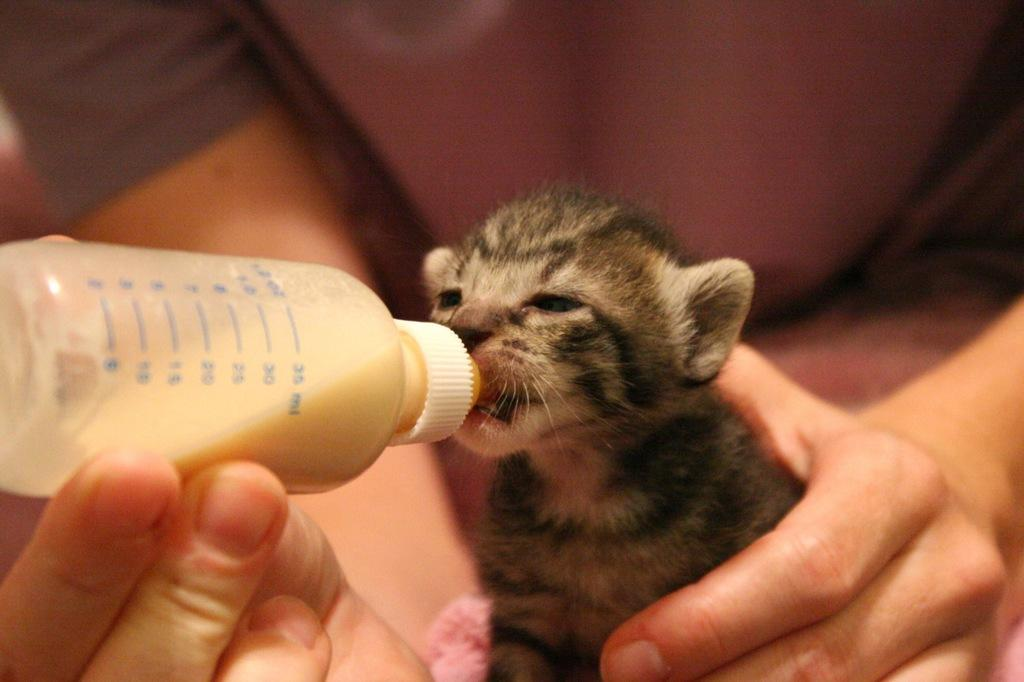What is the main subject of the image? There is a person in the image. What is the person holding in their left hand? The person is holding a bottle in their left hand. What is the person holding in their right hand? The person is holding an animal in their right hand. What is the person doing with the animal? The person is feeding the animal. What type of thunder can be heard in the image? There is no thunder present in the image; it is a still image and does not contain any sounds. 